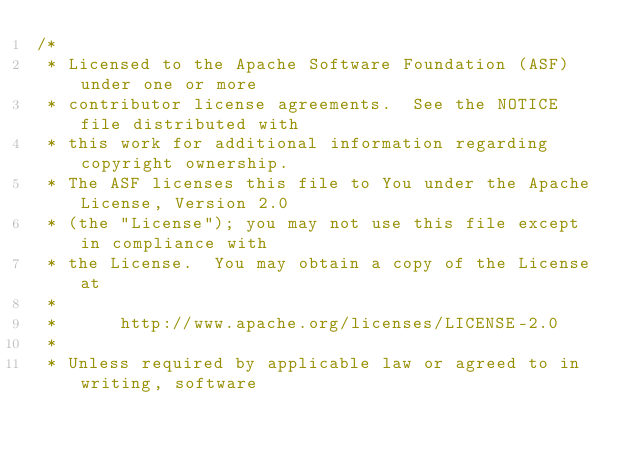Convert code to text. <code><loc_0><loc_0><loc_500><loc_500><_Java_>/*
 * Licensed to the Apache Software Foundation (ASF) under one or more
 * contributor license agreements.  See the NOTICE file distributed with
 * this work for additional information regarding copyright ownership.
 * The ASF licenses this file to You under the Apache License, Version 2.0
 * (the "License"); you may not use this file except in compliance with
 * the License.  You may obtain a copy of the License at
 *
 *      http://www.apache.org/licenses/LICENSE-2.0
 *
 * Unless required by applicable law or agreed to in writing, software</code> 